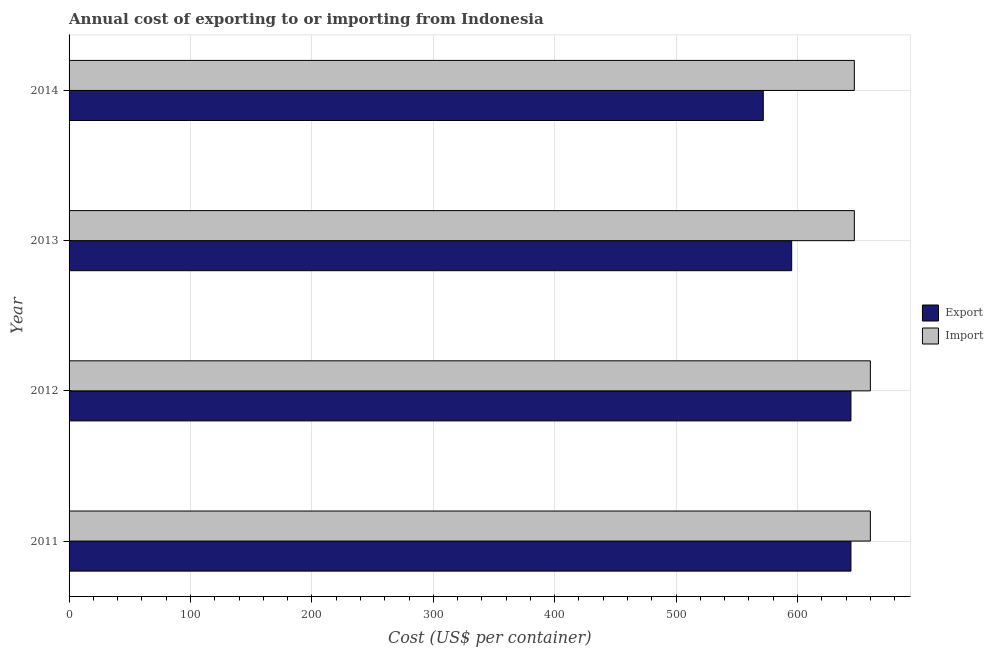How many different coloured bars are there?
Offer a very short reply. 2. How many groups of bars are there?
Your response must be concise. 4. Are the number of bars per tick equal to the number of legend labels?
Your answer should be compact. Yes. Are the number of bars on each tick of the Y-axis equal?
Your answer should be compact. Yes. How many bars are there on the 3rd tick from the bottom?
Offer a terse response. 2. What is the label of the 4th group of bars from the top?
Keep it short and to the point. 2011. What is the export cost in 2011?
Give a very brief answer. 644. Across all years, what is the maximum export cost?
Ensure brevity in your answer.  644. Across all years, what is the minimum export cost?
Offer a terse response. 571.8. In which year was the import cost maximum?
Make the answer very short. 2011. What is the total import cost in the graph?
Ensure brevity in your answer.  2613.6. What is the difference between the export cost in 2012 and the import cost in 2013?
Keep it short and to the point. -2.8. What is the average import cost per year?
Your answer should be very brief. 653.4. In the year 2013, what is the difference between the export cost and import cost?
Offer a terse response. -51.6. Is the export cost in 2011 less than that in 2013?
Offer a very short reply. No. Is the difference between the export cost in 2013 and 2014 greater than the difference between the import cost in 2013 and 2014?
Give a very brief answer. Yes. What is the difference between the highest and the second highest import cost?
Give a very brief answer. 0. What is the difference between the highest and the lowest export cost?
Your response must be concise. 72.2. Is the sum of the import cost in 2011 and 2013 greater than the maximum export cost across all years?
Your answer should be very brief. Yes. What does the 1st bar from the top in 2014 represents?
Provide a short and direct response. Import. What does the 1st bar from the bottom in 2012 represents?
Give a very brief answer. Export. How many bars are there?
Provide a short and direct response. 8. Are all the bars in the graph horizontal?
Ensure brevity in your answer.  Yes. What is the title of the graph?
Offer a very short reply. Annual cost of exporting to or importing from Indonesia. Does "Urban" appear as one of the legend labels in the graph?
Keep it short and to the point. No. What is the label or title of the X-axis?
Ensure brevity in your answer.  Cost (US$ per container). What is the label or title of the Y-axis?
Give a very brief answer. Year. What is the Cost (US$ per container) of Export in 2011?
Offer a very short reply. 644. What is the Cost (US$ per container) of Import in 2011?
Provide a succinct answer. 660. What is the Cost (US$ per container) in Export in 2012?
Offer a very short reply. 644. What is the Cost (US$ per container) of Import in 2012?
Make the answer very short. 660. What is the Cost (US$ per container) in Export in 2013?
Provide a short and direct response. 595.2. What is the Cost (US$ per container) of Import in 2013?
Provide a succinct answer. 646.8. What is the Cost (US$ per container) in Export in 2014?
Your response must be concise. 571.8. What is the Cost (US$ per container) of Import in 2014?
Keep it short and to the point. 646.8. Across all years, what is the maximum Cost (US$ per container) in Export?
Your response must be concise. 644. Across all years, what is the maximum Cost (US$ per container) in Import?
Make the answer very short. 660. Across all years, what is the minimum Cost (US$ per container) of Export?
Make the answer very short. 571.8. Across all years, what is the minimum Cost (US$ per container) in Import?
Your answer should be compact. 646.8. What is the total Cost (US$ per container) of Export in the graph?
Provide a short and direct response. 2455. What is the total Cost (US$ per container) in Import in the graph?
Provide a short and direct response. 2613.6. What is the difference between the Cost (US$ per container) in Export in 2011 and that in 2012?
Offer a very short reply. 0. What is the difference between the Cost (US$ per container) in Export in 2011 and that in 2013?
Keep it short and to the point. 48.8. What is the difference between the Cost (US$ per container) in Export in 2011 and that in 2014?
Your answer should be very brief. 72.2. What is the difference between the Cost (US$ per container) in Import in 2011 and that in 2014?
Make the answer very short. 13.2. What is the difference between the Cost (US$ per container) in Export in 2012 and that in 2013?
Ensure brevity in your answer.  48.8. What is the difference between the Cost (US$ per container) in Import in 2012 and that in 2013?
Your answer should be compact. 13.2. What is the difference between the Cost (US$ per container) in Export in 2012 and that in 2014?
Make the answer very short. 72.2. What is the difference between the Cost (US$ per container) of Export in 2013 and that in 2014?
Provide a short and direct response. 23.4. What is the difference between the Cost (US$ per container) of Export in 2011 and the Cost (US$ per container) of Import in 2012?
Your answer should be very brief. -16. What is the difference between the Cost (US$ per container) of Export in 2011 and the Cost (US$ per container) of Import in 2013?
Offer a very short reply. -2.8. What is the difference between the Cost (US$ per container) in Export in 2011 and the Cost (US$ per container) in Import in 2014?
Ensure brevity in your answer.  -2.8. What is the difference between the Cost (US$ per container) in Export in 2012 and the Cost (US$ per container) in Import in 2014?
Provide a succinct answer. -2.8. What is the difference between the Cost (US$ per container) of Export in 2013 and the Cost (US$ per container) of Import in 2014?
Ensure brevity in your answer.  -51.6. What is the average Cost (US$ per container) in Export per year?
Make the answer very short. 613.75. What is the average Cost (US$ per container) of Import per year?
Keep it short and to the point. 653.4. In the year 2011, what is the difference between the Cost (US$ per container) in Export and Cost (US$ per container) in Import?
Provide a succinct answer. -16. In the year 2013, what is the difference between the Cost (US$ per container) of Export and Cost (US$ per container) of Import?
Make the answer very short. -51.6. In the year 2014, what is the difference between the Cost (US$ per container) in Export and Cost (US$ per container) in Import?
Your answer should be compact. -75. What is the ratio of the Cost (US$ per container) of Export in 2011 to that in 2012?
Offer a terse response. 1. What is the ratio of the Cost (US$ per container) in Import in 2011 to that in 2012?
Your response must be concise. 1. What is the ratio of the Cost (US$ per container) of Export in 2011 to that in 2013?
Your answer should be compact. 1.08. What is the ratio of the Cost (US$ per container) in Import in 2011 to that in 2013?
Offer a terse response. 1.02. What is the ratio of the Cost (US$ per container) of Export in 2011 to that in 2014?
Ensure brevity in your answer.  1.13. What is the ratio of the Cost (US$ per container) of Import in 2011 to that in 2014?
Your response must be concise. 1.02. What is the ratio of the Cost (US$ per container) in Export in 2012 to that in 2013?
Your answer should be very brief. 1.08. What is the ratio of the Cost (US$ per container) of Import in 2012 to that in 2013?
Provide a short and direct response. 1.02. What is the ratio of the Cost (US$ per container) in Export in 2012 to that in 2014?
Your answer should be compact. 1.13. What is the ratio of the Cost (US$ per container) of Import in 2012 to that in 2014?
Provide a short and direct response. 1.02. What is the ratio of the Cost (US$ per container) in Export in 2013 to that in 2014?
Ensure brevity in your answer.  1.04. What is the ratio of the Cost (US$ per container) of Import in 2013 to that in 2014?
Your answer should be very brief. 1. What is the difference between the highest and the second highest Cost (US$ per container) of Export?
Your answer should be very brief. 0. What is the difference between the highest and the lowest Cost (US$ per container) in Export?
Give a very brief answer. 72.2. 